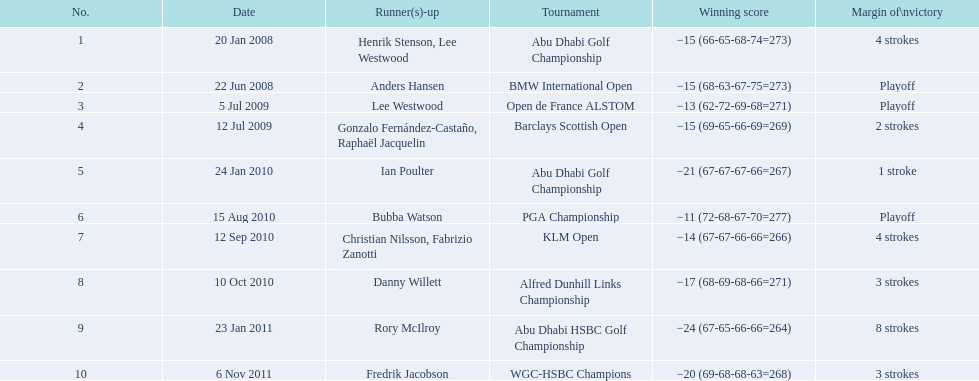What were all the different tournaments played by martin kaymer Abu Dhabi Golf Championship, BMW International Open, Open de France ALSTOM, Barclays Scottish Open, Abu Dhabi Golf Championship, PGA Championship, KLM Open, Alfred Dunhill Links Championship, Abu Dhabi HSBC Golf Championship, WGC-HSBC Champions. Who was the runner-up for the pga championship? Bubba Watson. 